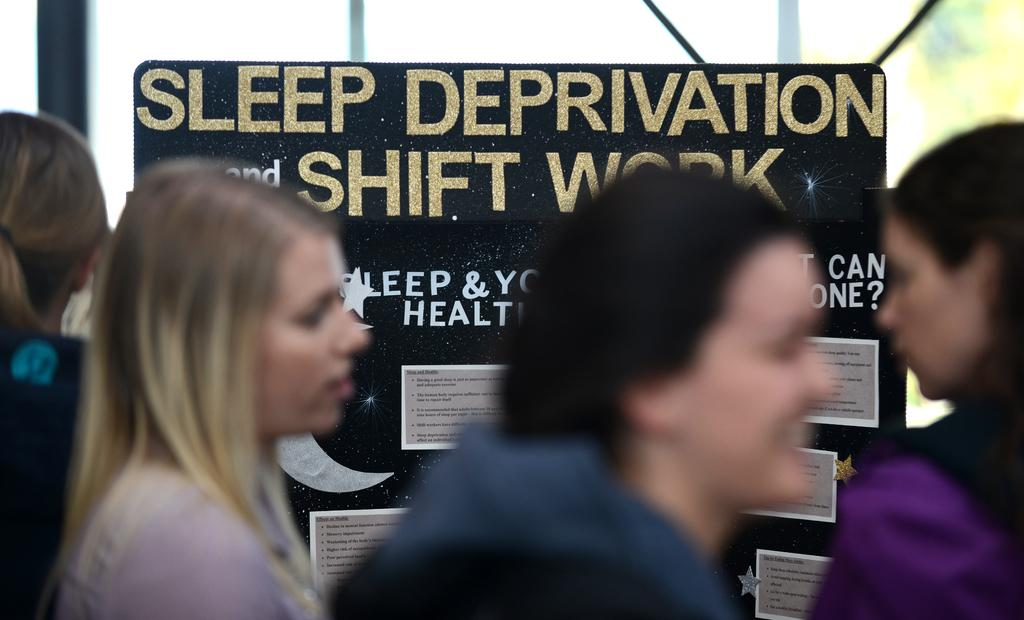How many people are in the image? There are four persons in the image. What is the main object in the image? There is a board in the image. What is written or displayed on the board? There is text on the board, and there are also posters on the board. What can be seen in the background of the image? There are poles visible in the background of the image. Is there a map of the prison displayed on the board in the image? There is no map or prison mentioned in the image. The board contains text and posters, but no map or prison-related content. 